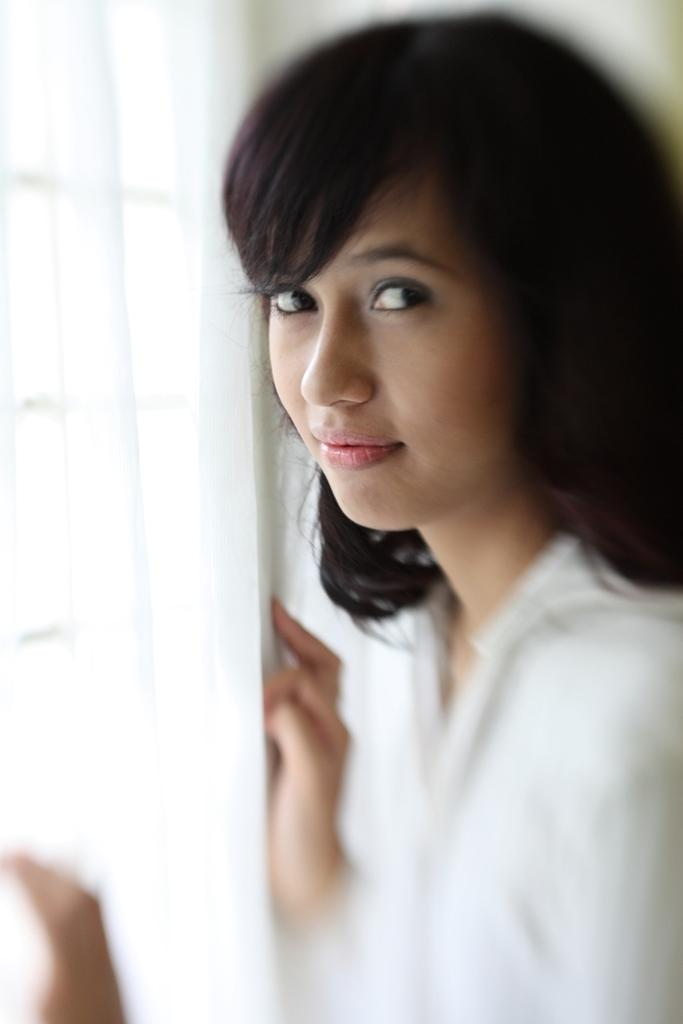Who is present on the right side of the image? There is a woman on the right side of the image. What is the woman doing in the image? The woman is looking at a picture. What can be seen on the left side of the image? There is a window on the left side of the image. What type of foot injury can be seen on the woman in the image? There is no foot injury visible on the woman in the image. Is there a bridge present in the image? No, there is no bridge present in the image. 